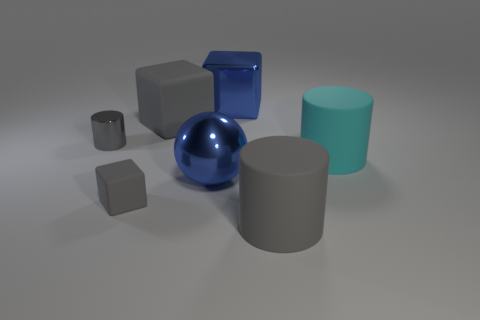Are the big cyan thing and the large gray object to the right of the large blue sphere made of the same material?
Your response must be concise. Yes. Are there any shiny spheres behind the large cyan matte object?
Offer a terse response. No. How many objects are large red blocks or big gray things that are on the right side of the big gray rubber cube?
Your answer should be very brief. 1. The shiny thing that is right of the blue object in front of the big blue cube is what color?
Your answer should be compact. Blue. What number of other things are made of the same material as the big blue block?
Keep it short and to the point. 2. How many metal objects are either green cylinders or cyan cylinders?
Ensure brevity in your answer.  0. What color is the other large object that is the same shape as the cyan thing?
Your response must be concise. Gray. How many things are large gray matte cubes or cyan objects?
Offer a very short reply. 2. There is a big gray object that is the same material as the large gray cylinder; what is its shape?
Offer a terse response. Cube. How many big things are yellow metal things or blue blocks?
Make the answer very short. 1. 